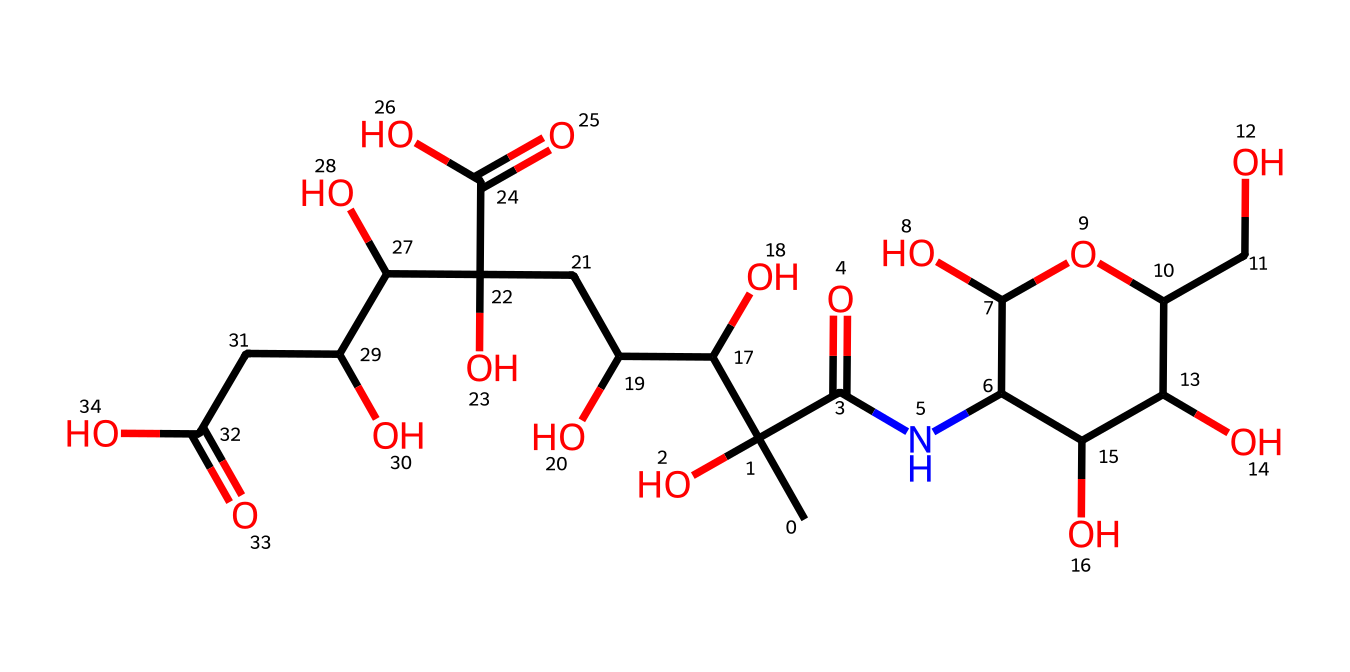How many carbon atoms are present in this chemical? To find the number of carbon atoms, I can analyze the SMILES representation and count each "C". The chemical structure contains 15 carbon atoms as observable from the string.
Answer: 15 What is the functional group represented in the structure? In the provided SMILES, the presence of "C(=O)" indicates carbonyl groups, and "O" indicates hydroxyl groups (alcohols). Specifically, the repeating units suggest multiple hydroxyl groups, characteristic of a polyol structure.
Answer: hydroxyl groups How many total oxygen atoms are in this compound? I can examine the SMILES and count the total occurrences of "O". There are 10 oxygen atoms indicated in the SMILES, which confirms their presence in various functional groups throughout the molecule.
Answer: 10 What type of chemical structure is this compound categorized as? The arrangement of the atoms and the presence of multiple hydroxyl groups suggest that this chemical has the properties typical of polysaccharides, specifically a glycosaminoglycan. This is evident through its structural features that function in hydration and viscosity.
Answer: glycosaminoglycan How does the structure of hyaluronic acid contribute to its function in artificial tears? The presence of numerous hydroxyl groups allows for extensive hydrogen bonding with water, which enhances moisture retention. Its large molecular structure and ability to maintain hydration are critical for ocular surface lubrication.
Answer: moisture retention 